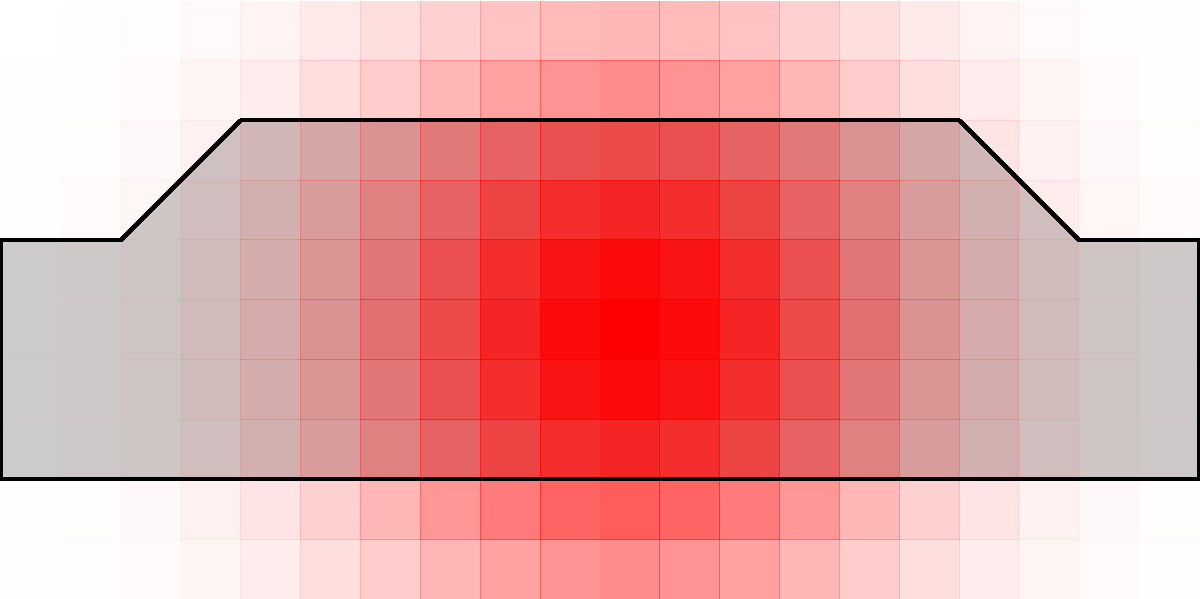Based on the heatmap overlay on this car design, which area of the vehicle appears to attract the most visual attention from viewers? To analyze the visual appeal of car designs using heatmaps, we need to follow these steps:

1. Understand the heatmap: In this image, the red overlay represents viewer attention. The more intense (darker) the red, the more attention that area receives.

2. Identify the car's main sections: We can divide the car into front, middle (cabin), and rear sections.

3. Analyze the intensity distribution:
   - The front section shows the highest concentration of dark red.
   - The middle section (cabin area) has a moderate intensity of red.
   - The rear section has the least amount of red overlay.

4. Compare intensities: The front section clearly has the darkest and most concentrated red area, indicating it attracts the most visual attention.

5. Interpret the results: In car design, the front section often includes key design elements like the grille, headlights, and hood, which are crucial for brand identity and visual appeal.

Given this analysis, we can conclude that the front section of the car attracts the most visual attention from viewers.
Answer: Front section 